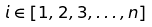Convert formula to latex. <formula><loc_0><loc_0><loc_500><loc_500>i \in [ 1 , 2 , 3 , \dots , n ]</formula> 